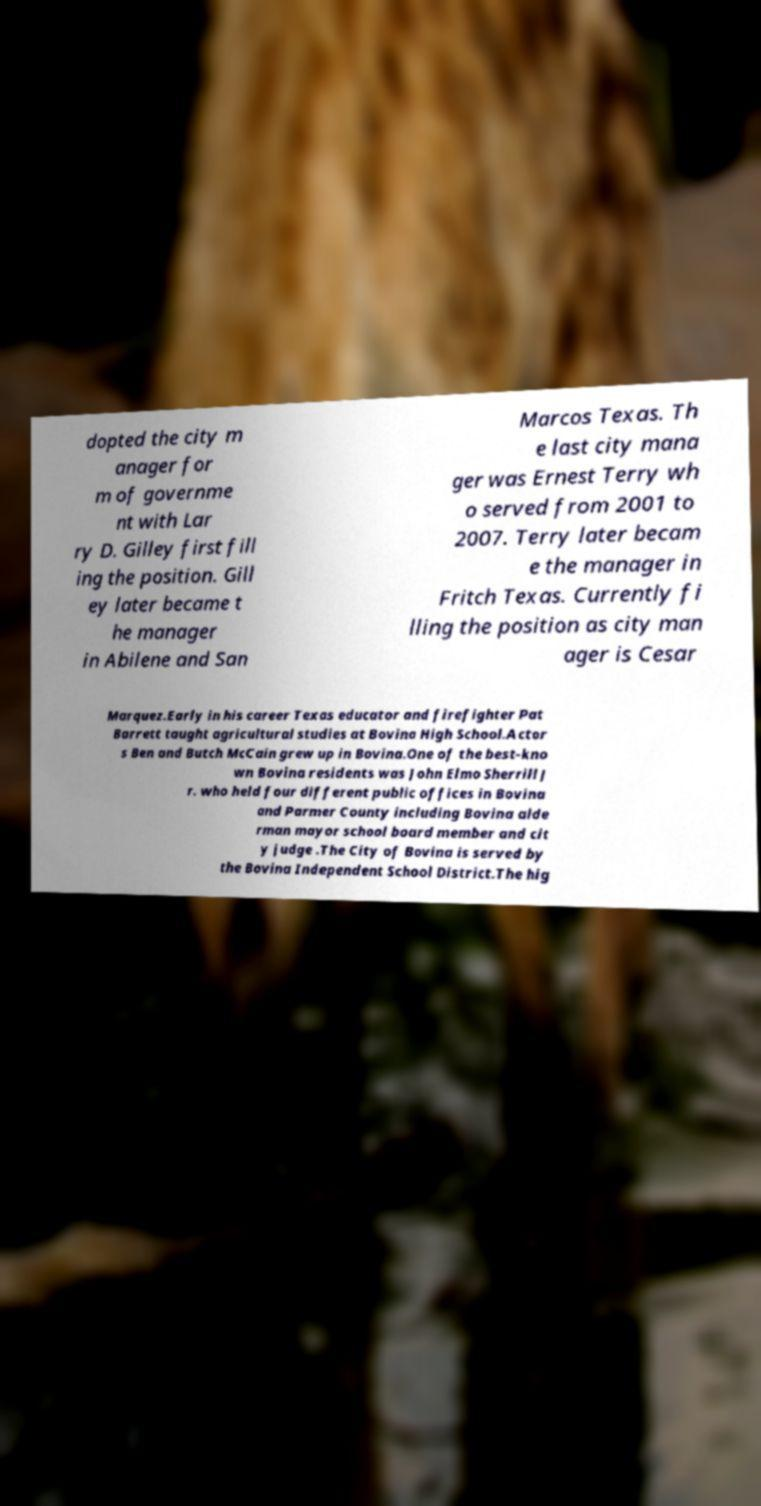Could you assist in decoding the text presented in this image and type it out clearly? dopted the city m anager for m of governme nt with Lar ry D. Gilley first fill ing the position. Gill ey later became t he manager in Abilene and San Marcos Texas. Th e last city mana ger was Ernest Terry wh o served from 2001 to 2007. Terry later becam e the manager in Fritch Texas. Currently fi lling the position as city man ager is Cesar Marquez.Early in his career Texas educator and firefighter Pat Barrett taught agricultural studies at Bovina High School.Actor s Ben and Butch McCain grew up in Bovina.One of the best-kno wn Bovina residents was John Elmo Sherrill J r. who held four different public offices in Bovina and Parmer County including Bovina alde rman mayor school board member and cit y judge .The City of Bovina is served by the Bovina Independent School District.The hig 